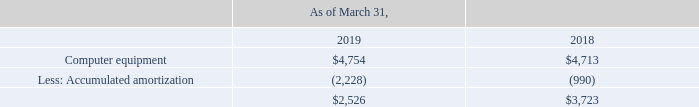(2) Includes property and equipment acquired under capital leases:
Depreciation and amortization expense was $25.2 million, $17.5 million, and $11.8 million for the years ended March 31, 2019, 2018 and 2017, respectively. Depreciation and amortization expense in the years ended March 31, 2019, 2018 and 2017 included $1.2 million, $0.9 million and $0.1 million related to property and equipment acquired under capital leases.
How much was Depreciation and amortization expense for the years ended March 31, 2019? $25.2 million. How much was Depreciation and amortization expense for the years ended March 31, 2018? $17.5 million. How much was Depreciation and amortization expense for the years ended March 31, 2017? $11.8 million. What is the change in Computer equipment from March 31, 2018 to March 31, 2019? 4,754-4,713
Answer: 41. What is the change in Accumulated amortization from March 31, 2018 to March 31, 2019? 2,228-990
Answer: 1238. What is the average Computer equipment for March 31, 2018 to March 31, 2019? (4,754+4,713) / 2
Answer: 4733.5. 